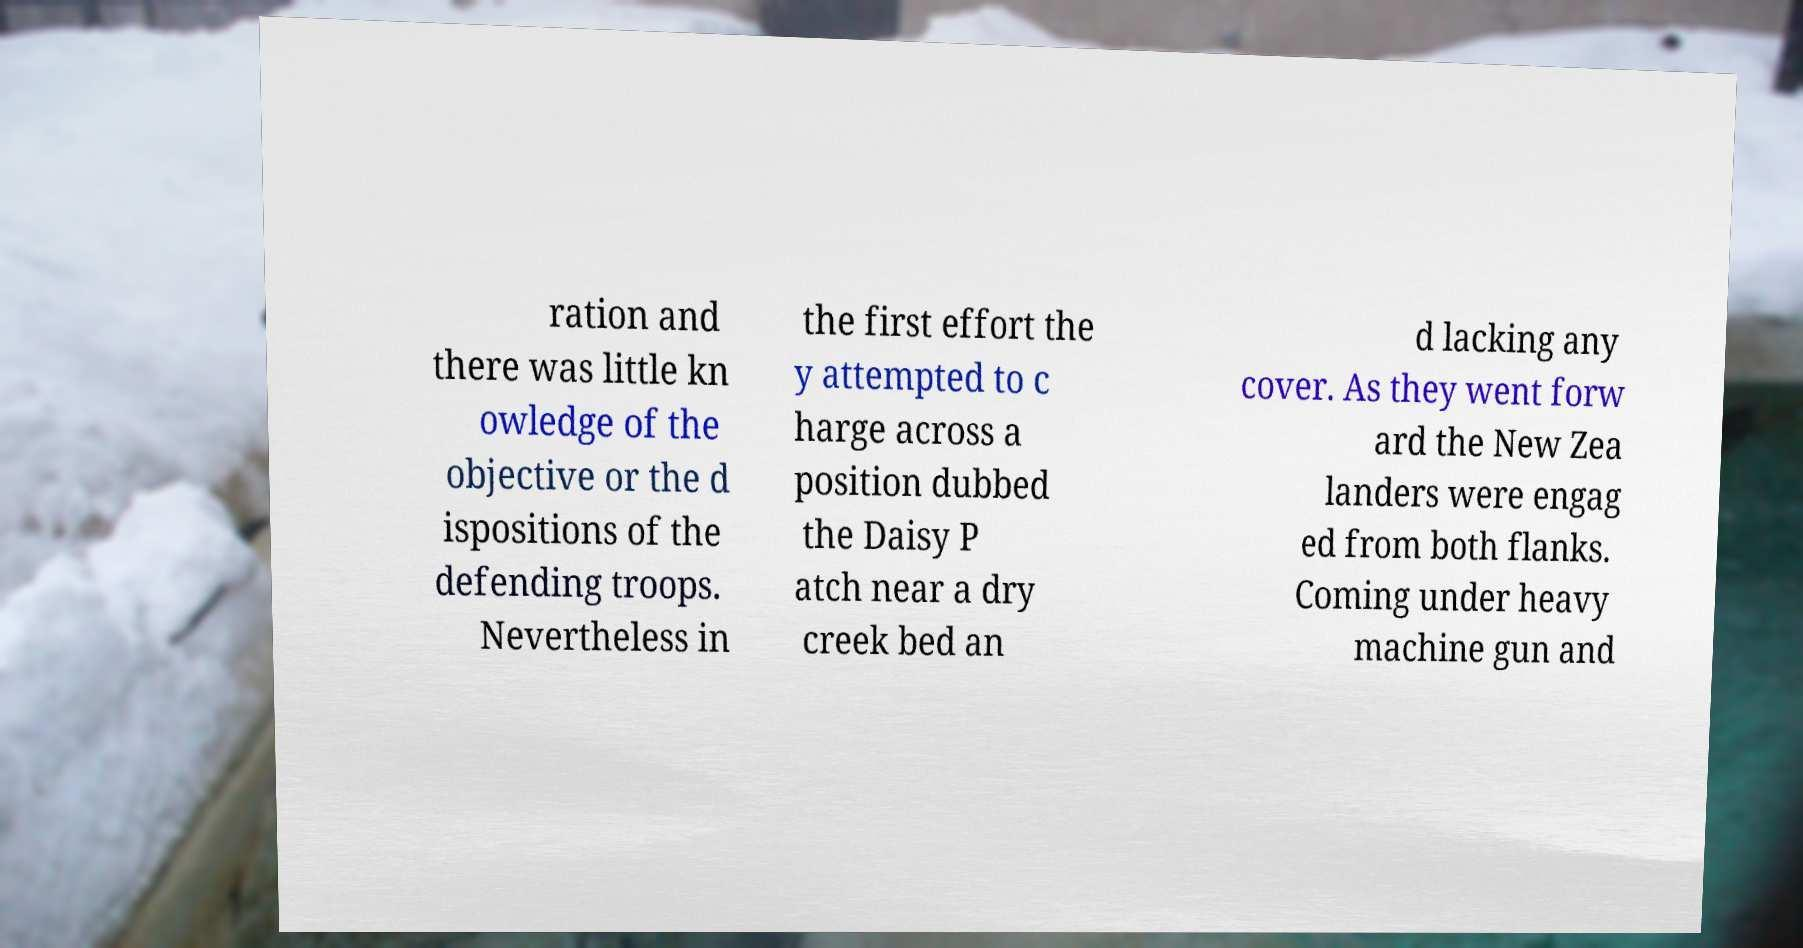Could you extract and type out the text from this image? ration and there was little kn owledge of the objective or the d ispositions of the defending troops. Nevertheless in the first effort the y attempted to c harge across a position dubbed the Daisy P atch near a dry creek bed an d lacking any cover. As they went forw ard the New Zea landers were engag ed from both flanks. Coming under heavy machine gun and 